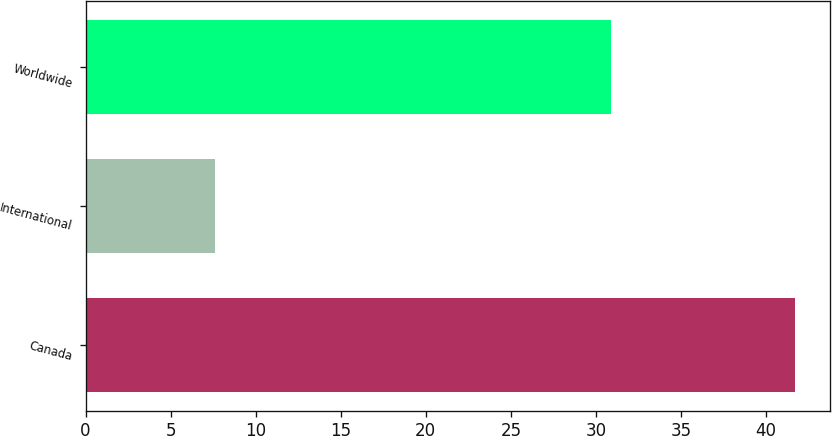Convert chart to OTSL. <chart><loc_0><loc_0><loc_500><loc_500><bar_chart><fcel>Canada<fcel>International<fcel>Worldwide<nl><fcel>41.7<fcel>7.6<fcel>30.9<nl></chart> 